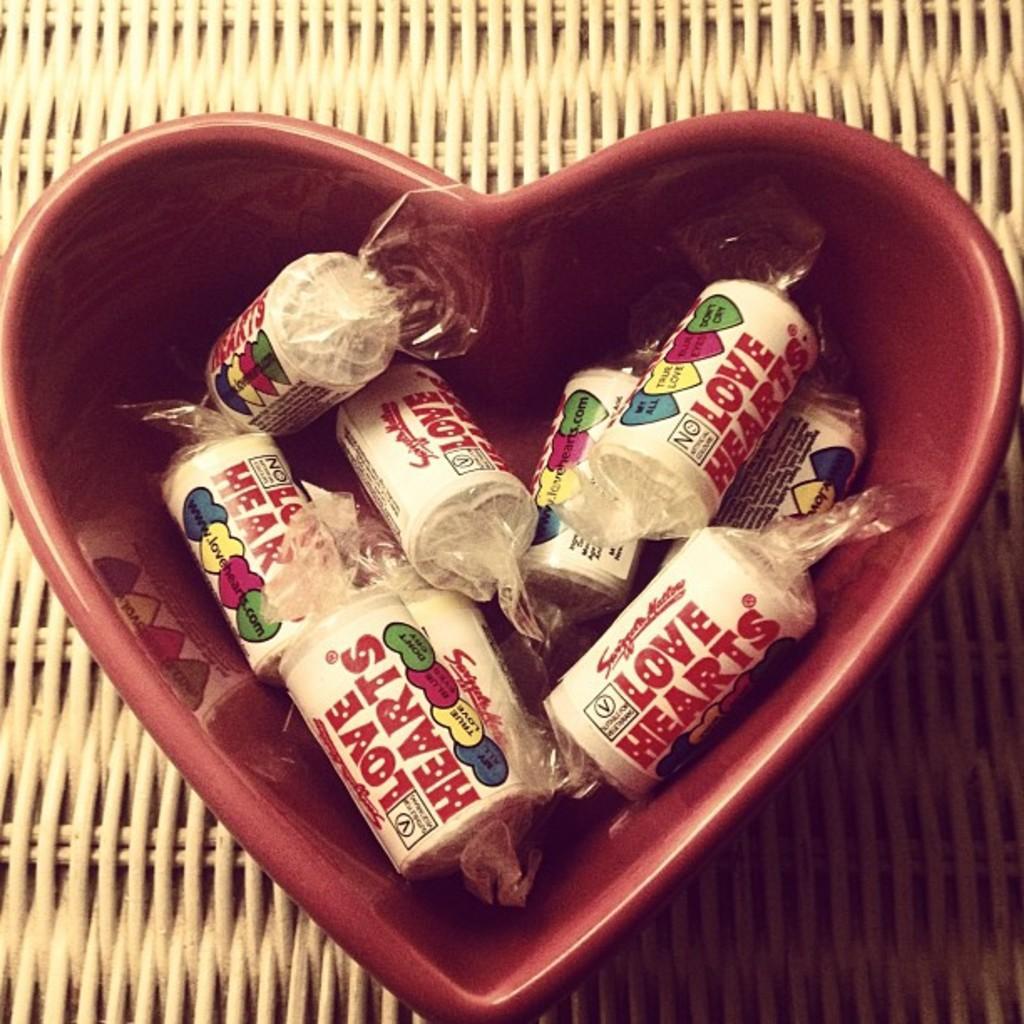How would you summarize this image in a sentence or two? In this image I can see a container of heart shape. 